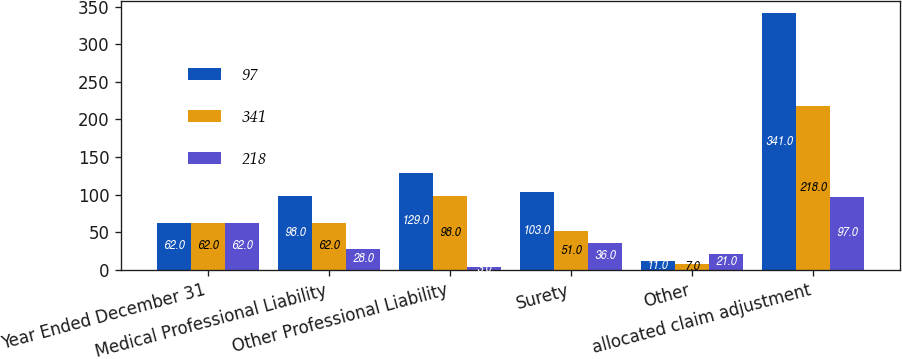Convert chart. <chart><loc_0><loc_0><loc_500><loc_500><stacked_bar_chart><ecel><fcel>Year Ended December 31<fcel>Medical Professional Liability<fcel>Other Professional Liability<fcel>Surety<fcel>Other<fcel>allocated claim adjustment<nl><fcel>97<fcel>62<fcel>98<fcel>129<fcel>103<fcel>11<fcel>341<nl><fcel>341<fcel>62<fcel>62<fcel>98<fcel>51<fcel>7<fcel>218<nl><fcel>218<fcel>62<fcel>28<fcel>3<fcel>36<fcel>21<fcel>97<nl></chart> 